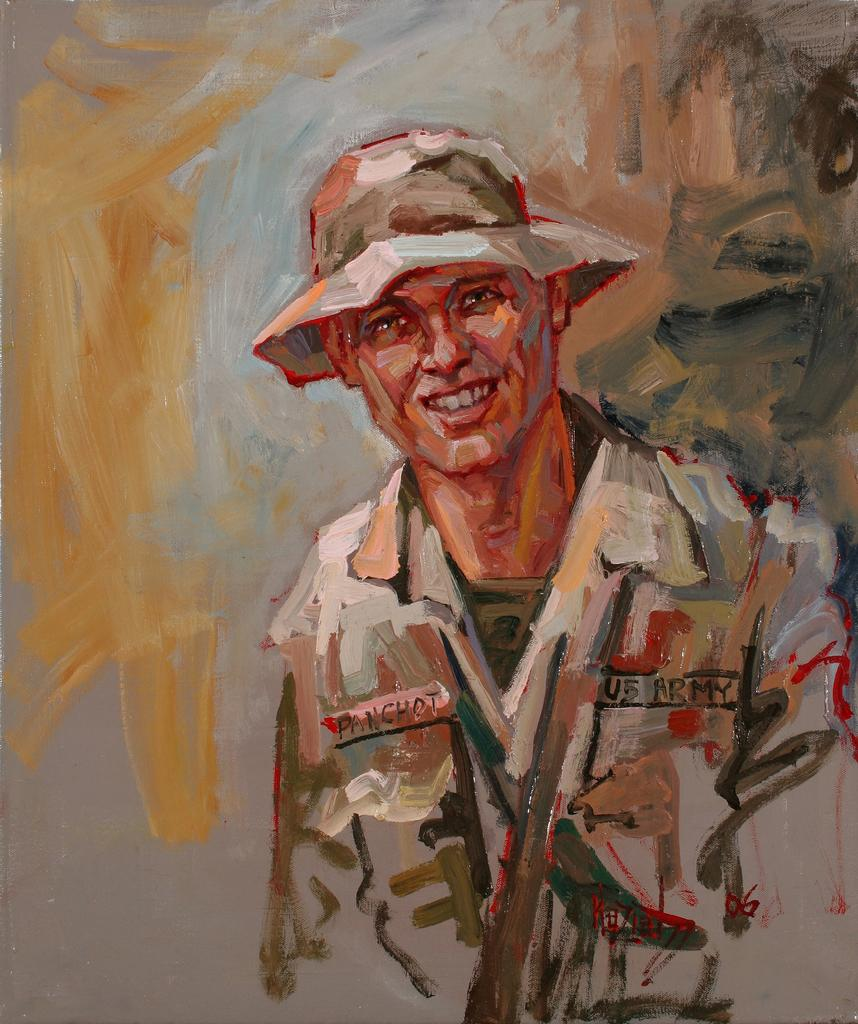What is the main subject of the image? There is a painting in the image. What does the painting depict? The painting depicts a man. What is the man wearing in the painting? The man is wearing a hat. What can be seen in the background of the painting? There are different colors visible in the background of the painting. How does the man in the painting try to achieve peace with the camera? There is no camera present in the painting, and the man's actions or intentions are not depicted. 